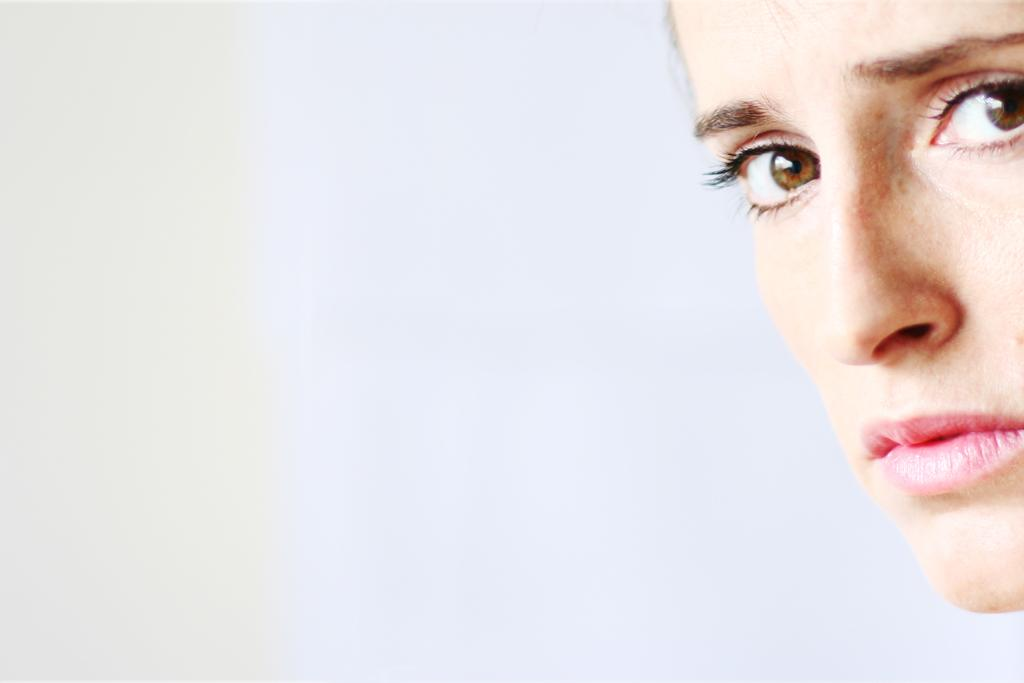What is the main subject of the image? There is a person's face in the image. What color is the background of the image? The background of the image is white. Can you see any smoke coming from the person's toes in the image? There are no toes or smoke present in the image; it only features a person's face against a white background. 